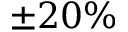Convert formula to latex. <formula><loc_0><loc_0><loc_500><loc_500>\pm 2 0 \%</formula> 